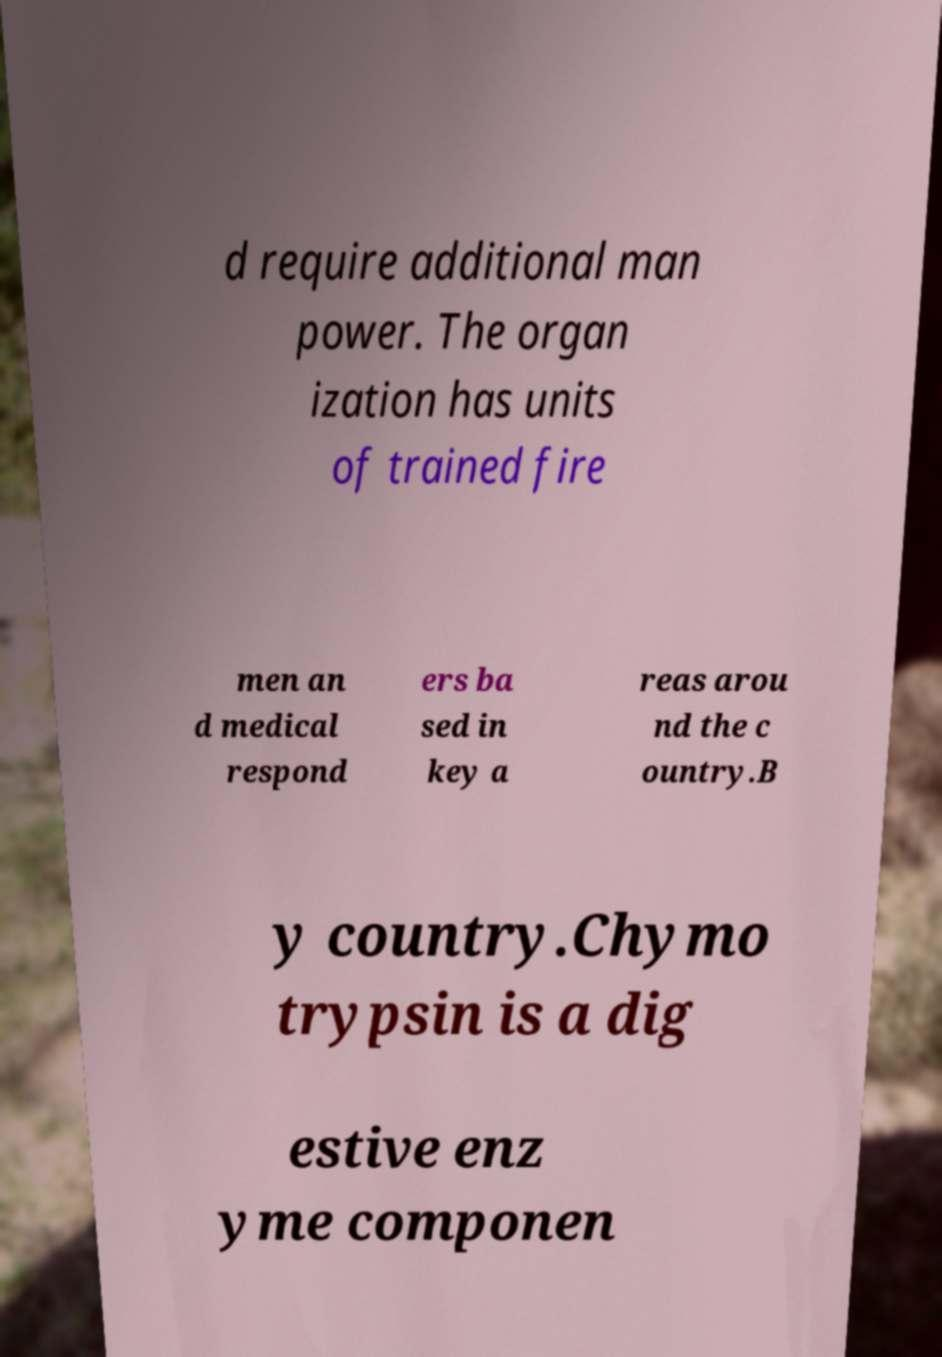Can you read and provide the text displayed in the image?This photo seems to have some interesting text. Can you extract and type it out for me? d require additional man power. The organ ization has units of trained fire men an d medical respond ers ba sed in key a reas arou nd the c ountry.B y country.Chymo trypsin is a dig estive enz yme componen 